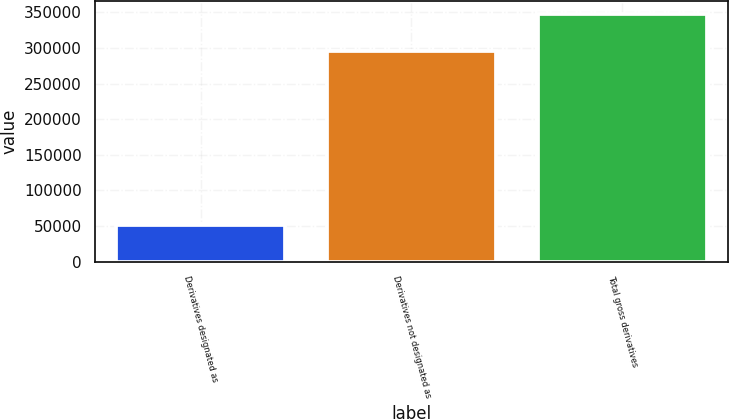Convert chart. <chart><loc_0><loc_0><loc_500><loc_500><bar_chart><fcel>Derivatives designated as<fcel>Derivatives not designated as<fcel>Total gross derivatives<nl><fcel>52074<fcel>295902<fcel>347976<nl></chart> 